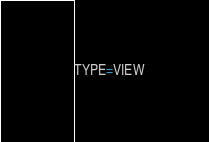Convert code to text. <code><loc_0><loc_0><loc_500><loc_500><_VisualBasic_>TYPE=VIEW</code> 